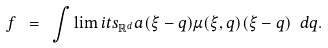Convert formula to latex. <formula><loc_0><loc_0><loc_500><loc_500>f \ = \ \int \lim i t s _ { \mathbb { R } ^ { d } } a ( \xi - q ) \mu ( \xi , q ) ( \xi - q ) \ d q .</formula> 